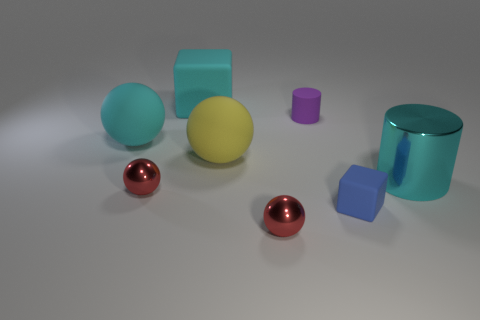The blue thing is what shape?
Provide a short and direct response. Cube. There is a purple thing that is the same shape as the cyan metallic object; what is it made of?
Offer a terse response. Rubber. The sphere that is both on the left side of the big yellow ball and right of the cyan rubber ball is what color?
Your response must be concise. Red. Are the cylinder that is behind the cyan cylinder and the cube behind the purple rubber thing made of the same material?
Give a very brief answer. Yes. Are there more large cyan metallic objects in front of the big matte cube than matte cylinders in front of the big metal object?
Make the answer very short. Yes. There is a shiny thing that is the same size as the yellow rubber thing; what shape is it?
Offer a terse response. Cylinder. How many things are either big yellow matte objects or rubber cubes that are on the left side of the purple matte thing?
Provide a short and direct response. 2. Do the large metallic thing and the tiny cube have the same color?
Offer a terse response. No. How many cyan metal objects are in front of the large yellow rubber thing?
Provide a short and direct response. 1. The other block that is the same material as the small blue cube is what color?
Offer a terse response. Cyan. 